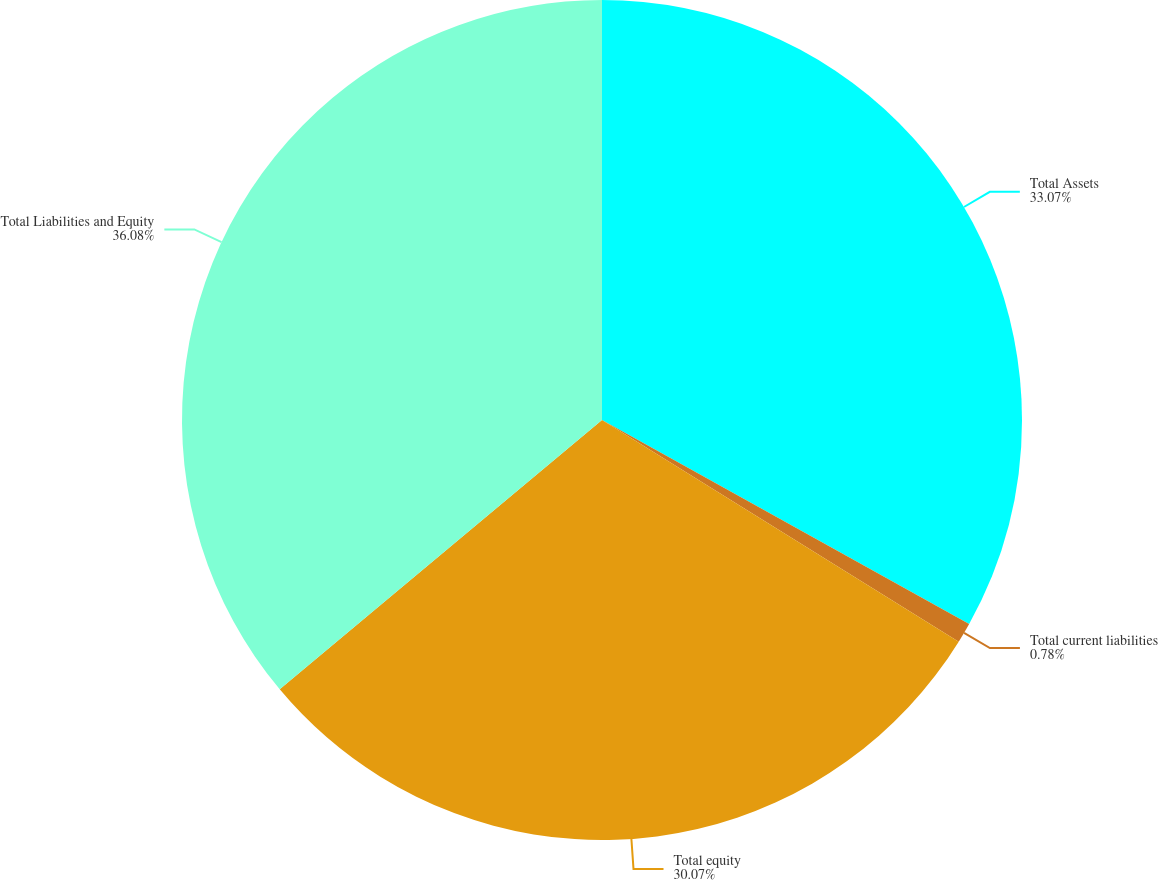Convert chart. <chart><loc_0><loc_0><loc_500><loc_500><pie_chart><fcel>Total Assets<fcel>Total current liabilities<fcel>Total equity<fcel>Total Liabilities and Equity<nl><fcel>33.07%<fcel>0.78%<fcel>30.07%<fcel>36.08%<nl></chart> 